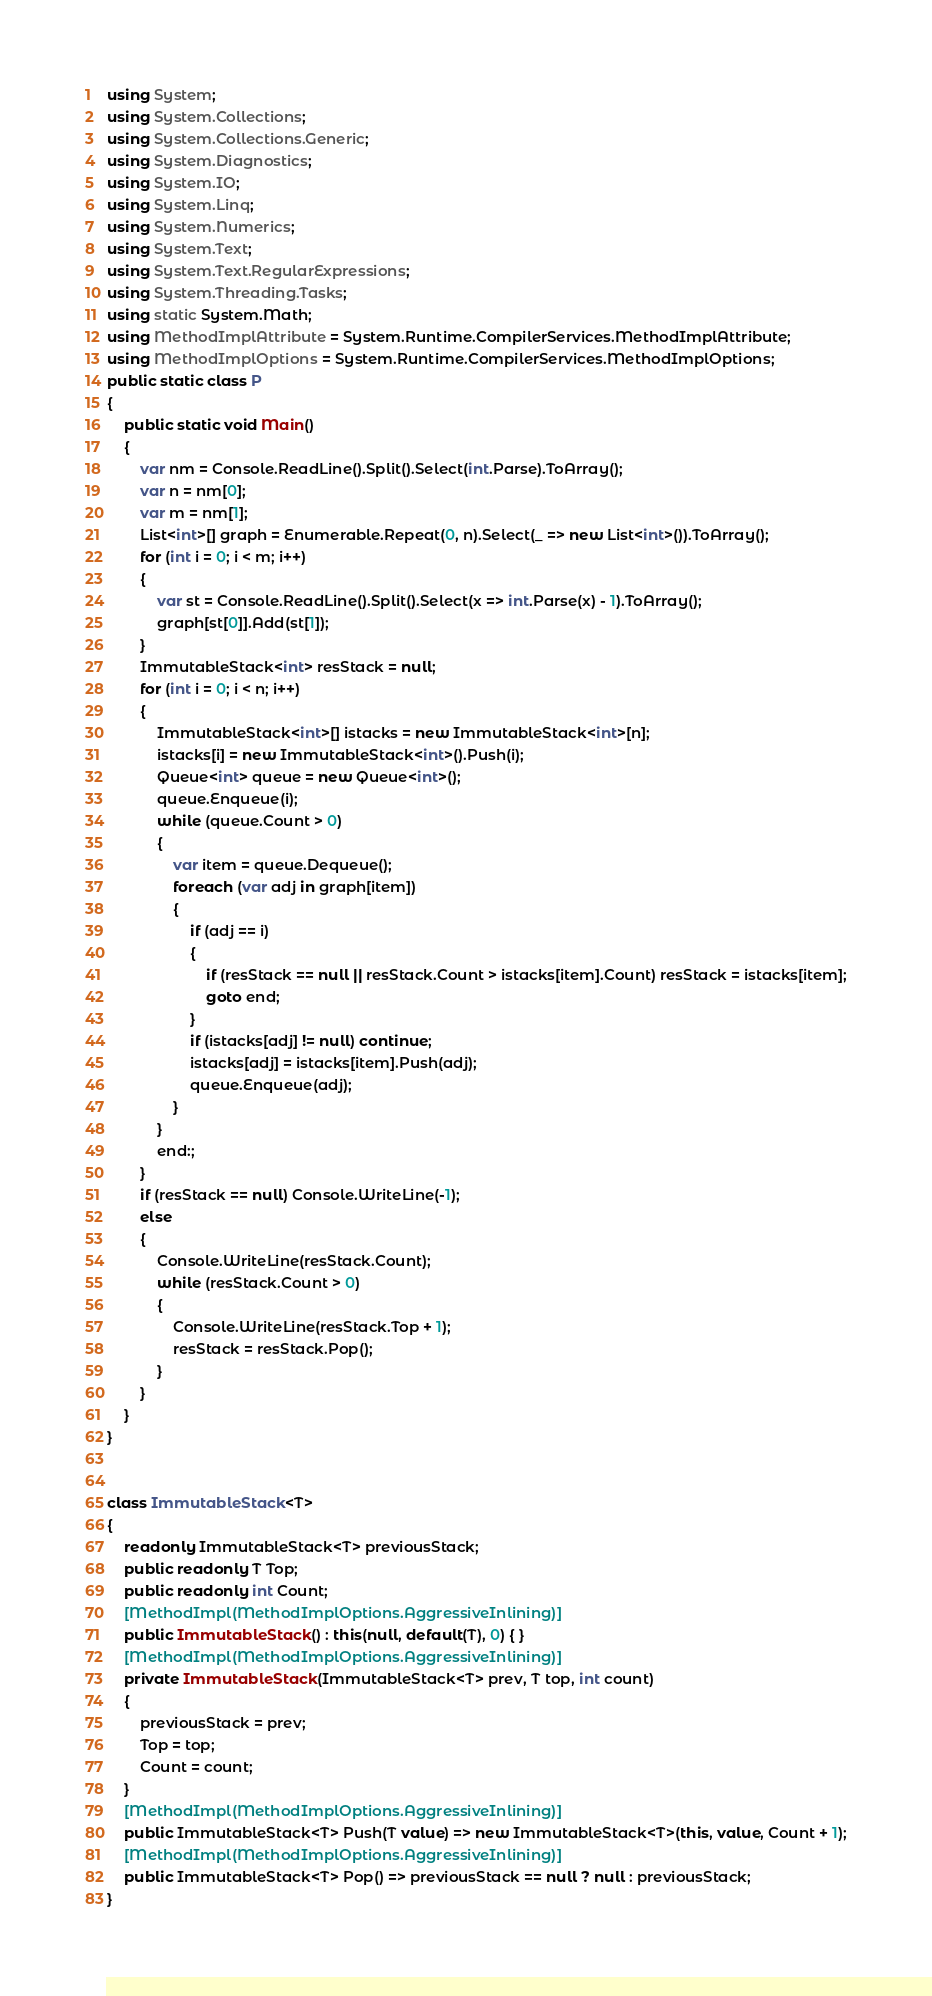<code> <loc_0><loc_0><loc_500><loc_500><_C#_>using System;
using System.Collections;
using System.Collections.Generic;
using System.Diagnostics;
using System.IO;
using System.Linq;
using System.Numerics;
using System.Text;
using System.Text.RegularExpressions;
using System.Threading.Tasks;
using static System.Math;
using MethodImplAttribute = System.Runtime.CompilerServices.MethodImplAttribute;
using MethodImplOptions = System.Runtime.CompilerServices.MethodImplOptions;
public static class P
{
    public static void Main()
    {
        var nm = Console.ReadLine().Split().Select(int.Parse).ToArray();
        var n = nm[0];
        var m = nm[1];
        List<int>[] graph = Enumerable.Repeat(0, n).Select(_ => new List<int>()).ToArray();
        for (int i = 0; i < m; i++)
        {
            var st = Console.ReadLine().Split().Select(x => int.Parse(x) - 1).ToArray();
            graph[st[0]].Add(st[1]);
        }
        ImmutableStack<int> resStack = null;
        for (int i = 0; i < n; i++)
        {
            ImmutableStack<int>[] istacks = new ImmutableStack<int>[n];
            istacks[i] = new ImmutableStack<int>().Push(i);
            Queue<int> queue = new Queue<int>();
            queue.Enqueue(i);
            while (queue.Count > 0)
            {
                var item = queue.Dequeue();
                foreach (var adj in graph[item])
                {
                    if (adj == i)
                    {
                        if (resStack == null || resStack.Count > istacks[item].Count) resStack = istacks[item];
                        goto end;
                    }
                    if (istacks[adj] != null) continue;
                    istacks[adj] = istacks[item].Push(adj);
                    queue.Enqueue(adj);
                }
            }
            end:;
        }
        if (resStack == null) Console.WriteLine(-1);
        else
        {
            Console.WriteLine(resStack.Count);
            while (resStack.Count > 0)
            {
                Console.WriteLine(resStack.Top + 1);
                resStack = resStack.Pop();
            }
        }
    }
}


class ImmutableStack<T>
{
    readonly ImmutableStack<T> previousStack;
    public readonly T Top;
    public readonly int Count;
    [MethodImpl(MethodImplOptions.AggressiveInlining)]
    public ImmutableStack() : this(null, default(T), 0) { }
    [MethodImpl(MethodImplOptions.AggressiveInlining)]
    private ImmutableStack(ImmutableStack<T> prev, T top, int count)
    {
        previousStack = prev;
        Top = top;
        Count = count;
    }
    [MethodImpl(MethodImplOptions.AggressiveInlining)]
    public ImmutableStack<T> Push(T value) => new ImmutableStack<T>(this, value, Count + 1);
    [MethodImpl(MethodImplOptions.AggressiveInlining)]
    public ImmutableStack<T> Pop() => previousStack == null ? null : previousStack;
}
</code> 